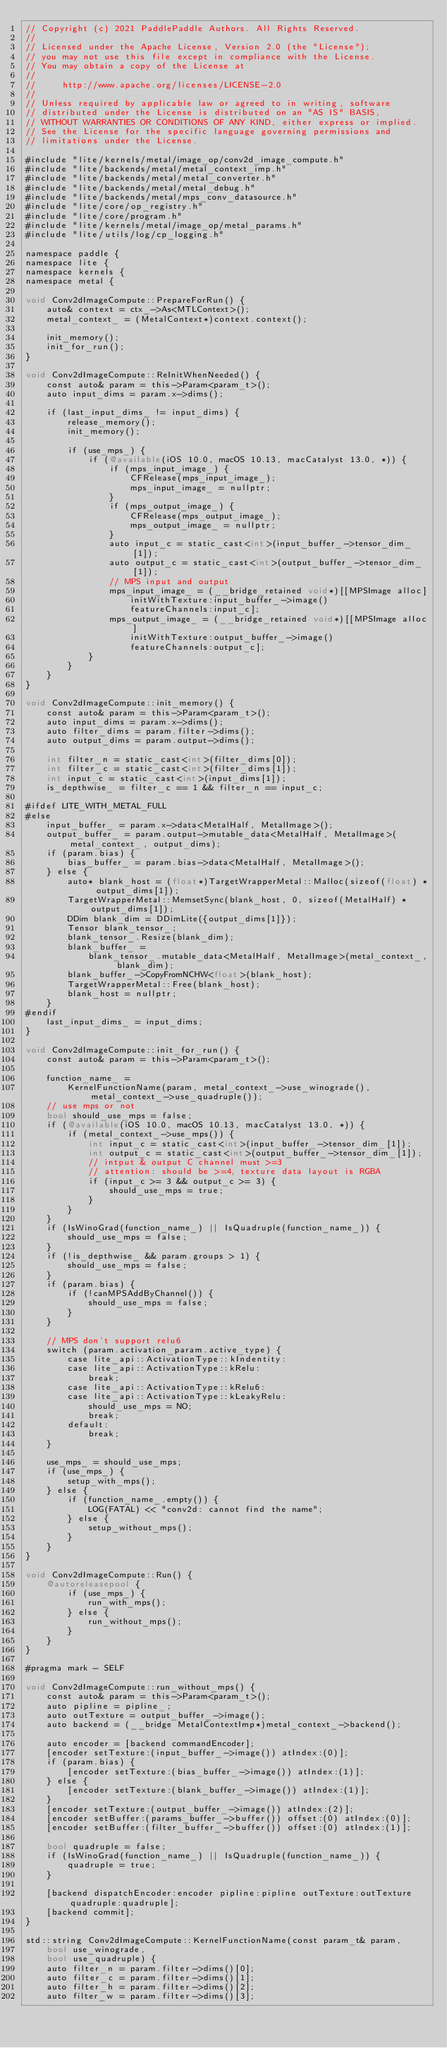<code> <loc_0><loc_0><loc_500><loc_500><_ObjectiveC_>// Copyright (c) 2021 PaddlePaddle Authors. All Rights Reserved.
//
// Licensed under the Apache License, Version 2.0 (the "License");
// you may not use this file except in compliance with the License.
// You may obtain a copy of the License at
//
//     http://www.apache.org/licenses/LICENSE-2.0
//
// Unless required by applicable law or agreed to in writing, software
// distributed under the License is distributed on an "AS IS" BASIS,
// WITHOUT WARRANTIES OR CONDITIONS OF ANY KIND, either express or implied.
// See the License for the specific language governing permissions and
// limitations under the License.

#include "lite/kernels/metal/image_op/conv2d_image_compute.h"
#include "lite/backends/metal/metal_context_imp.h"
#include "lite/backends/metal/metal_converter.h"
#include "lite/backends/metal/metal_debug.h"
#include "lite/backends/metal/mps_conv_datasource.h"
#include "lite/core/op_registry.h"
#include "lite/core/program.h"
#include "lite/kernels/metal/image_op/metal_params.h"
#include "lite/utils/log/cp_logging.h"

namespace paddle {
namespace lite {
namespace kernels {
namespace metal {

void Conv2dImageCompute::PrepareForRun() {
    auto& context = ctx_->As<MTLContext>();
    metal_context_ = (MetalContext*)context.context();

    init_memory();
    init_for_run();
}

void Conv2dImageCompute::ReInitWhenNeeded() {
    const auto& param = this->Param<param_t>();
    auto input_dims = param.x->dims();

    if (last_input_dims_ != input_dims) {
        release_memory();
        init_memory();

        if (use_mps_) {
            if (@available(iOS 10.0, macOS 10.13, macCatalyst 13.0, *)) {
                if (mps_input_image_) {
                    CFRelease(mps_input_image_);
                    mps_input_image_ = nullptr;
                }
                if (mps_output_image_) {
                    CFRelease(mps_output_image_);
                    mps_output_image_ = nullptr;
                }
                auto input_c = static_cast<int>(input_buffer_->tensor_dim_[1]);
                auto output_c = static_cast<int>(output_buffer_->tensor_dim_[1]);
                // MPS input and output
                mps_input_image_ = (__bridge_retained void*)[[MPSImage alloc]
                    initWithTexture:input_buffer_->image()
                    featureChannels:input_c];
                mps_output_image_ = (__bridge_retained void*)[[MPSImage alloc]
                    initWithTexture:output_buffer_->image()
                    featureChannels:output_c];
            }
        }
    }
}

void Conv2dImageCompute::init_memory() {
    const auto& param = this->Param<param_t>();
    auto input_dims = param.x->dims();
    auto filter_dims = param.filter->dims();
    auto output_dims = param.output->dims();

    int filter_n = static_cast<int>(filter_dims[0]);
    int filter_c = static_cast<int>(filter_dims[1]);
    int input_c = static_cast<int>(input_dims[1]);
    is_depthwise_ = filter_c == 1 && filter_n == input_c;

#ifdef LITE_WITH_METAL_FULL
#else
    input_buffer_ = param.x->data<MetalHalf, MetalImage>();
    output_buffer_ = param.output->mutable_data<MetalHalf, MetalImage>(metal_context_, output_dims);
    if (param.bias) {
        bias_buffer_ = param.bias->data<MetalHalf, MetalImage>();
    } else {
        auto* blank_host = (float*)TargetWrapperMetal::Malloc(sizeof(float) * output_dims[1]);
        TargetWrapperMetal::MemsetSync(blank_host, 0, sizeof(MetalHalf) * output_dims[1]);
        DDim blank_dim = DDimLite({output_dims[1]});
        Tensor blank_tensor_;
        blank_tensor_.Resize(blank_dim);
        blank_buffer_ =
            blank_tensor_.mutable_data<MetalHalf, MetalImage>(metal_context_, blank_dim);
        blank_buffer_->CopyFromNCHW<float>(blank_host);
        TargetWrapperMetal::Free(blank_host);
        blank_host = nullptr;
    }
#endif
    last_input_dims_ = input_dims;
}

void Conv2dImageCompute::init_for_run() {
    const auto& param = this->Param<param_t>();

    function_name_ =
        KernelFunctionName(param, metal_context_->use_winograde(), metal_context_->use_quadruple());
    // use mps or not
    bool should_use_mps = false;
    if (@available(iOS 10.0, macOS 10.13, macCatalyst 13.0, *)) {
        if (metal_context_->use_mps()) {
            int input_c = static_cast<int>(input_buffer_->tensor_dim_[1]);
            int output_c = static_cast<int>(output_buffer_->tensor_dim_[1]);
            // intput & output C channel must >=3
            // attention: should be >=4, texture data layout is RGBA
            if (input_c >= 3 && output_c >= 3) {
                should_use_mps = true;
            }
        }
    }
    if (IsWinoGrad(function_name_) || IsQuadruple(function_name_)) {
        should_use_mps = false;
    }
    if (!is_depthwise_ && param.groups > 1) {
        should_use_mps = false;
    }
    if (param.bias) {
        if (!canMPSAddByChannel()) {
            should_use_mps = false;
        }
    }

    // MPS don't support relu6
    switch (param.activation_param.active_type) {
        case lite_api::ActivationType::kIndentity:
        case lite_api::ActivationType::kRelu:
            break;
        case lite_api::ActivationType::kRelu6:
        case lite_api::ActivationType::kLeakyRelu:
            should_use_mps = NO;
            break;
        default:
            break;
    }

    use_mps_ = should_use_mps;
    if (use_mps_) {
        setup_with_mps();
    } else {
        if (function_name_.empty()) {
            LOG(FATAL) << "conv2d: cannot find the name";
        } else {
            setup_without_mps();
        }
    }
}

void Conv2dImageCompute::Run() {
    @autoreleasepool {
        if (use_mps_) {
            run_with_mps();
        } else {
            run_without_mps();
        }
    }
}

#pragma mark - SELF

void Conv2dImageCompute::run_without_mps() {
    const auto& param = this->Param<param_t>();
    auto pipline = pipline_;
    auto outTexture = output_buffer_->image();
    auto backend = (__bridge MetalContextImp*)metal_context_->backend();

    auto encoder = [backend commandEncoder];
    [encoder setTexture:(input_buffer_->image()) atIndex:(0)];
    if (param.bias) {
        [encoder setTexture:(bias_buffer_->image()) atIndex:(1)];
    } else {
        [encoder setTexture:(blank_buffer_->image()) atIndex:(1)];
    }
    [encoder setTexture:(output_buffer_->image()) atIndex:(2)];
    [encoder setBuffer:(params_buffer_->buffer()) offset:(0) atIndex:(0)];
    [encoder setBuffer:(filter_buffer_->buffer()) offset:(0) atIndex:(1)];

    bool quadruple = false;
    if (IsWinoGrad(function_name_) || IsQuadruple(function_name_)) {
        quadruple = true;
    }

    [backend dispatchEncoder:encoder pipline:pipline outTexture:outTexture quadruple:quadruple];
    [backend commit];
}

std::string Conv2dImageCompute::KernelFunctionName(const param_t& param,
    bool use_winograde,
    bool use_quadruple) {
    auto filter_n = param.filter->dims()[0];
    auto filter_c = param.filter->dims()[1];
    auto filter_h = param.filter->dims()[2];
    auto filter_w = param.filter->dims()[3];</code> 